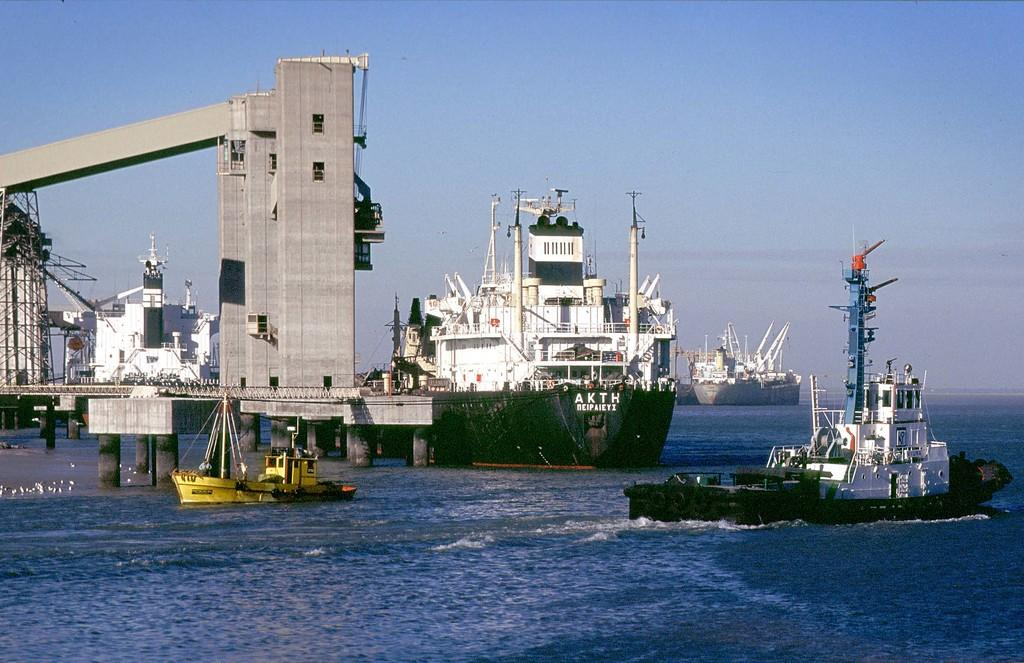<image>
Render a clear and concise summary of the photo. A huge freighter sits in the water with AKTH on its front section. 